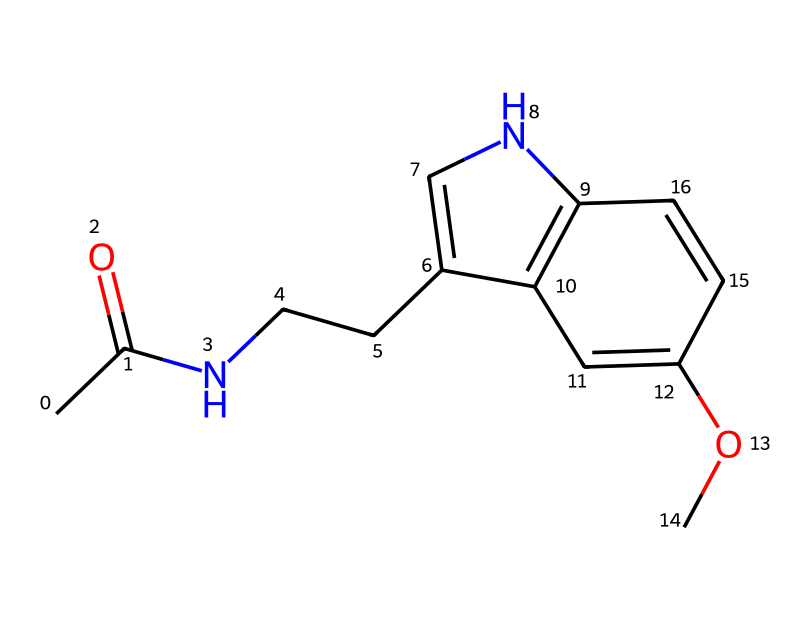What is the molecular formula of this compound? To determine the molecular formula from the SMILES representation, I identify the different atoms present. In the given SMILES, I count: 12 carbon (C) atoms, 15 hydrogen (H) atoms, 1 nitrogen (N) atom, and 2 oxygen (O) atoms. Therefore, the molecular formula can be constructed as C12H15N2O2.
Answer: C12H15N2O2 How many rings are present in the structure? By analyzing the connection of atoms in the SMILES, I detect two cyclic structures in the compound. The presence of sp2 hybridized carbon atoms and nitrogen atoms connected in a way that creates loops indicates there are two rings.
Answer: 2 What type of compound is melatonin classified as? Given that melatonin is primarily utilized for regulating sleep and has biological effects on the human body, it is classified as a medicinal compound, specifically a hormone and a sleep aid.
Answer: medicinal Which functional groups are present in this molecule? In the chemical structure, I identify that it contains an acetyl group (indicated by the presence of the carbonyl C=O and CH3) and methoxy group (C-O-CH3), among potential other groups. Thus, the recognized functional groups include an amide and ether.
Answer: amide, ether What is the primary use of melatonin in medicine? Based on the known pharmacological properties of melatonin, I conclude that its primary medicinal application is for the regulation of sleep patterns, particularly as a remedy for insomnia or issues related to shift work.
Answer: sleep aid How does the nitrogen atom contribute to the properties of melatonin? The nitrogen atom in melatonin is part of the indole structure which contributes to its biological activity and ability to interact with receptors in the body, such as those regulating circadian rhythms. This interaction implies a significant role in its effectiveness as a sleep regulator.
Answer: regulates sleep 